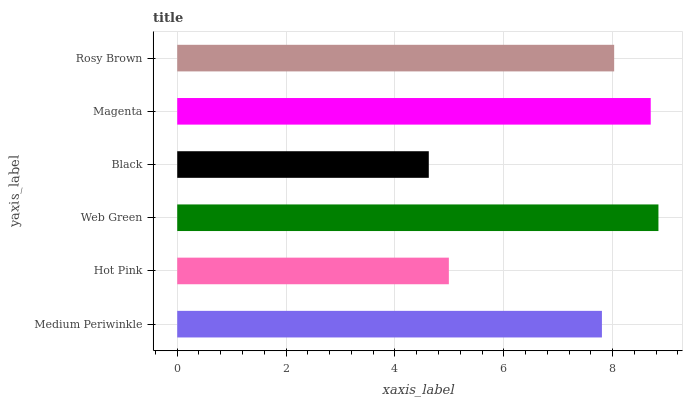Is Black the minimum?
Answer yes or no. Yes. Is Web Green the maximum?
Answer yes or no. Yes. Is Hot Pink the minimum?
Answer yes or no. No. Is Hot Pink the maximum?
Answer yes or no. No. Is Medium Periwinkle greater than Hot Pink?
Answer yes or no. Yes. Is Hot Pink less than Medium Periwinkle?
Answer yes or no. Yes. Is Hot Pink greater than Medium Periwinkle?
Answer yes or no. No. Is Medium Periwinkle less than Hot Pink?
Answer yes or no. No. Is Rosy Brown the high median?
Answer yes or no. Yes. Is Medium Periwinkle the low median?
Answer yes or no. Yes. Is Medium Periwinkle the high median?
Answer yes or no. No. Is Web Green the low median?
Answer yes or no. No. 